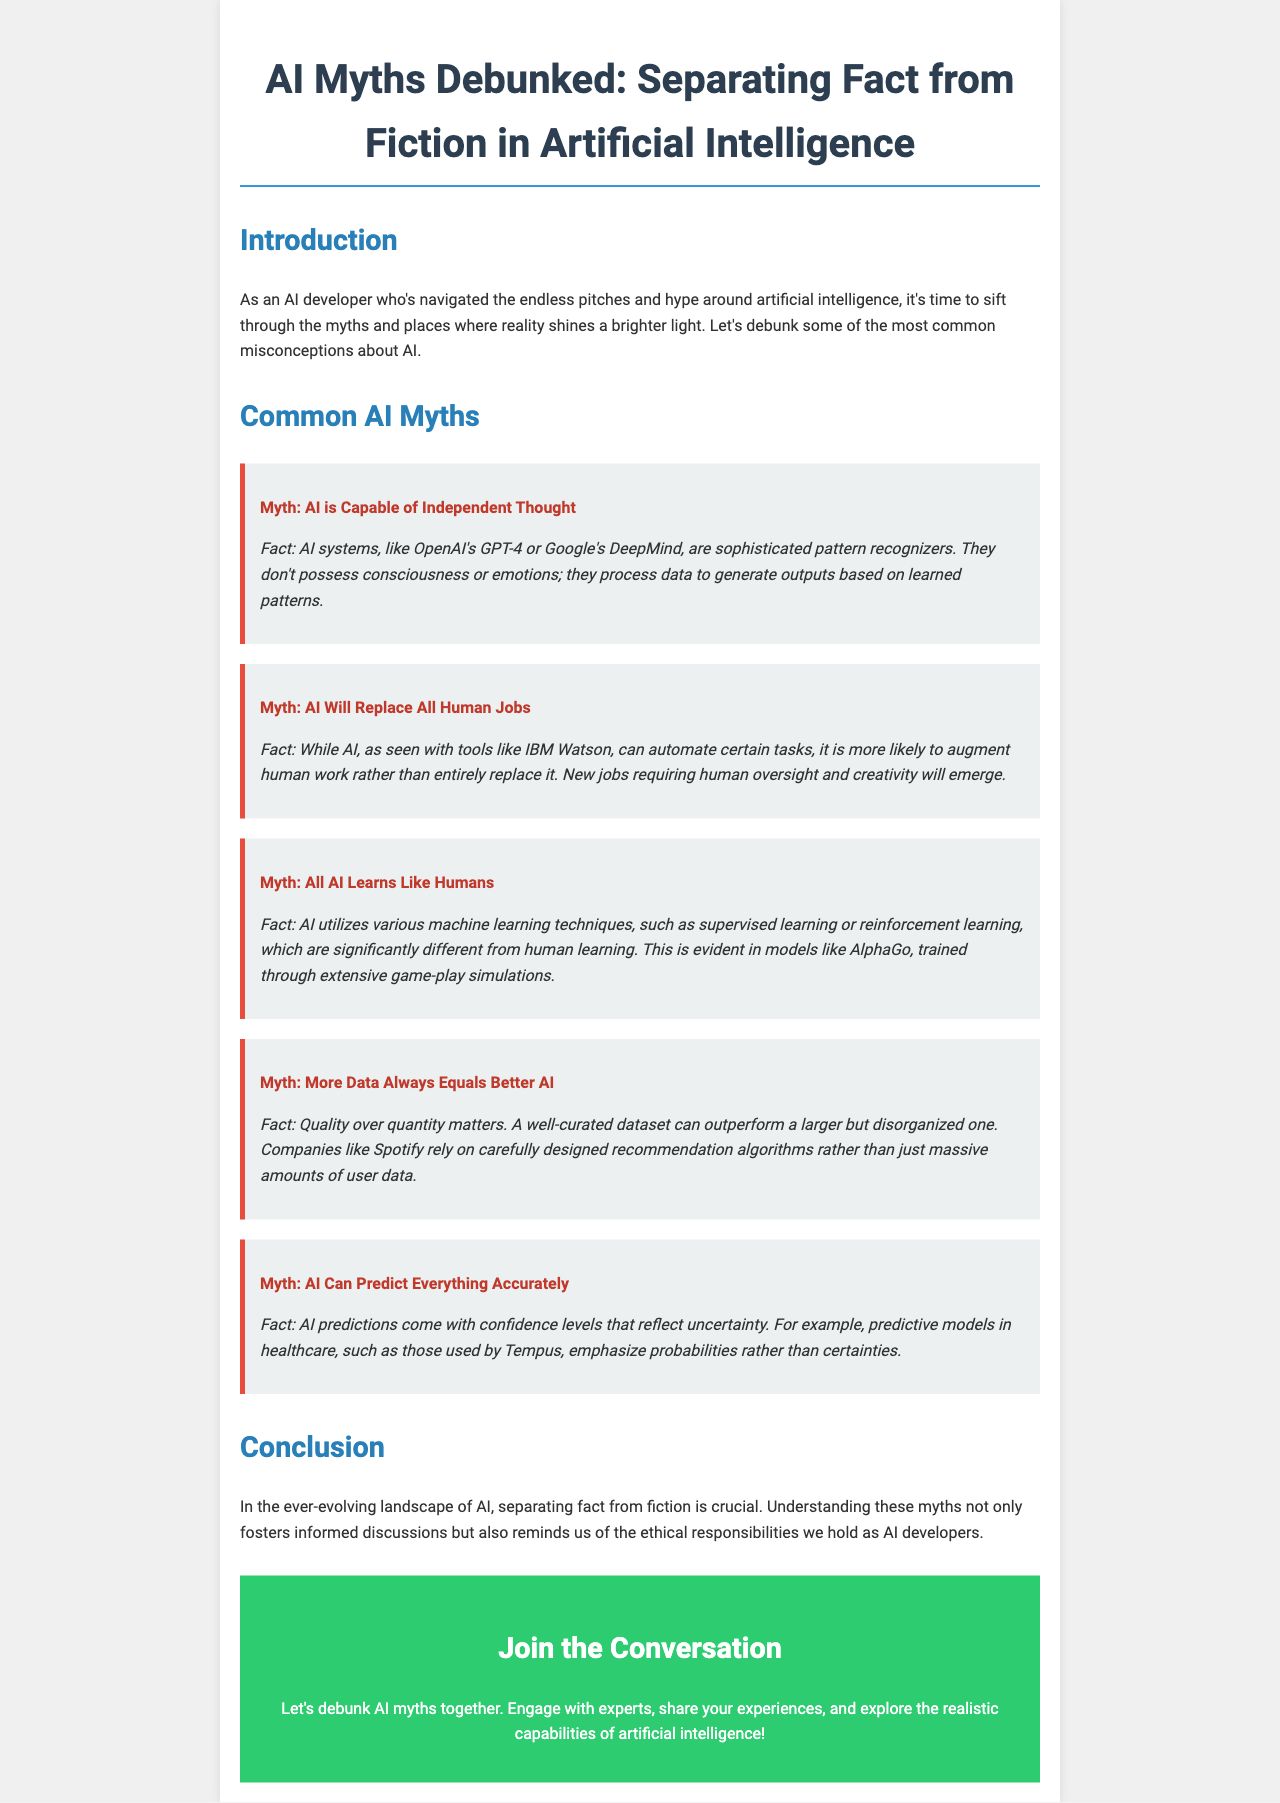What is the title of the document? The title of the document is prominently displayed at the top of the brochure.
Answer: AI Myths Debunked: Separating Fact from Fiction in Artificial Intelligence What is the first myth discussed? The first myth presented in the brochure is about AI's capabilities.
Answer: AI is Capable of Independent Thought What does the document say about AI's impact on jobs? The document discusses AI's potential impact on jobs, emphasizing how it functions.
Answer: AI Will Replace All Human Jobs How does AI learning differ from human learning? The document explains different types of learning in AI compared to human learning.
Answer: All AI Learns Like Humans What is emphasized as more important when it comes to data? The document highlights a key principle regarding data quality versus quantity.
Answer: Quality over quantity matters Which organization is mentioned in relation to predictive models in healthcare? The document references a specific company in the context of healthcare predictions.
Answer: Tempus What is the purpose of the final section titled "Join the Conversation"? The purpose of this section is to encourage engagement and discussion.
Answer: Engage with experts What is the color of the myth containers in the brochure? The brochure describes how the myth containers are visually distinguished.
Answer: #ecf0f1 What element frames the title of the brochure? The document specifies a graphic element used to highlight the title prominently.
Answer: 2px solid #3498db 